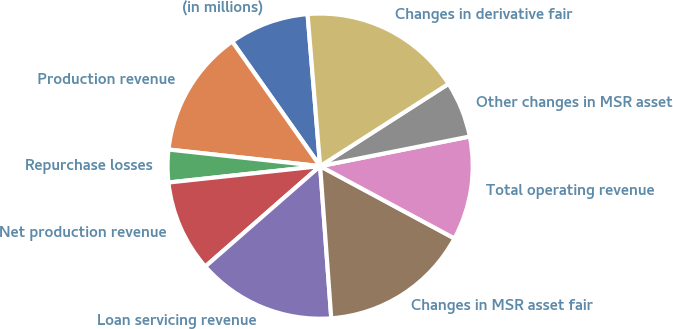<chart> <loc_0><loc_0><loc_500><loc_500><pie_chart><fcel>(in millions)<fcel>Production revenue<fcel>Repurchase losses<fcel>Net production revenue<fcel>Loan servicing revenue<fcel>Changes in MSR asset fair<fcel>Total operating revenue<fcel>Other changes in MSR asset<fcel>Changes in derivative fair<nl><fcel>8.47%<fcel>13.48%<fcel>3.45%<fcel>9.72%<fcel>14.73%<fcel>15.98%<fcel>10.97%<fcel>5.96%<fcel>17.24%<nl></chart> 